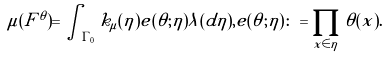<formula> <loc_0><loc_0><loc_500><loc_500>\mu ( F ^ { \theta } ) = \int _ { \Gamma _ { 0 } } k _ { \mu } ( \eta ) e ( \theta ; \eta ) \lambda ( d \eta ) , e ( \theta ; \eta ) \colon = \prod _ { x \in \eta } \theta ( x ) .</formula> 